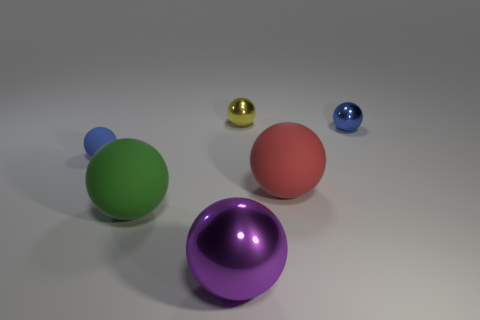Subtract all large red spheres. How many spheres are left? 5 Subtract all brown blocks. How many blue spheres are left? 2 Subtract 3 spheres. How many spheres are left? 3 Add 3 purple shiny balls. How many objects exist? 9 Subtract all yellow spheres. How many spheres are left? 5 Subtract all green balls. Subtract all gray blocks. How many balls are left? 5 Subtract 0 cyan cylinders. How many objects are left? 6 Subtract all cyan matte blocks. Subtract all large purple shiny balls. How many objects are left? 5 Add 1 tiny matte spheres. How many tiny matte spheres are left? 2 Add 5 small blue metallic things. How many small blue metallic things exist? 6 